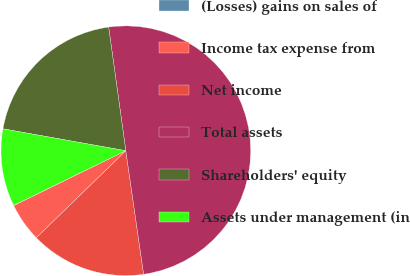Convert chart to OTSL. <chart><loc_0><loc_0><loc_500><loc_500><pie_chart><fcel>(Losses) gains on sales of<fcel>Income tax expense from<fcel>Net income<fcel>Total assets<fcel>Shareholders' equity<fcel>Assets under management (in<nl><fcel>0.04%<fcel>5.03%<fcel>15.0%<fcel>49.91%<fcel>19.99%<fcel>10.02%<nl></chart> 